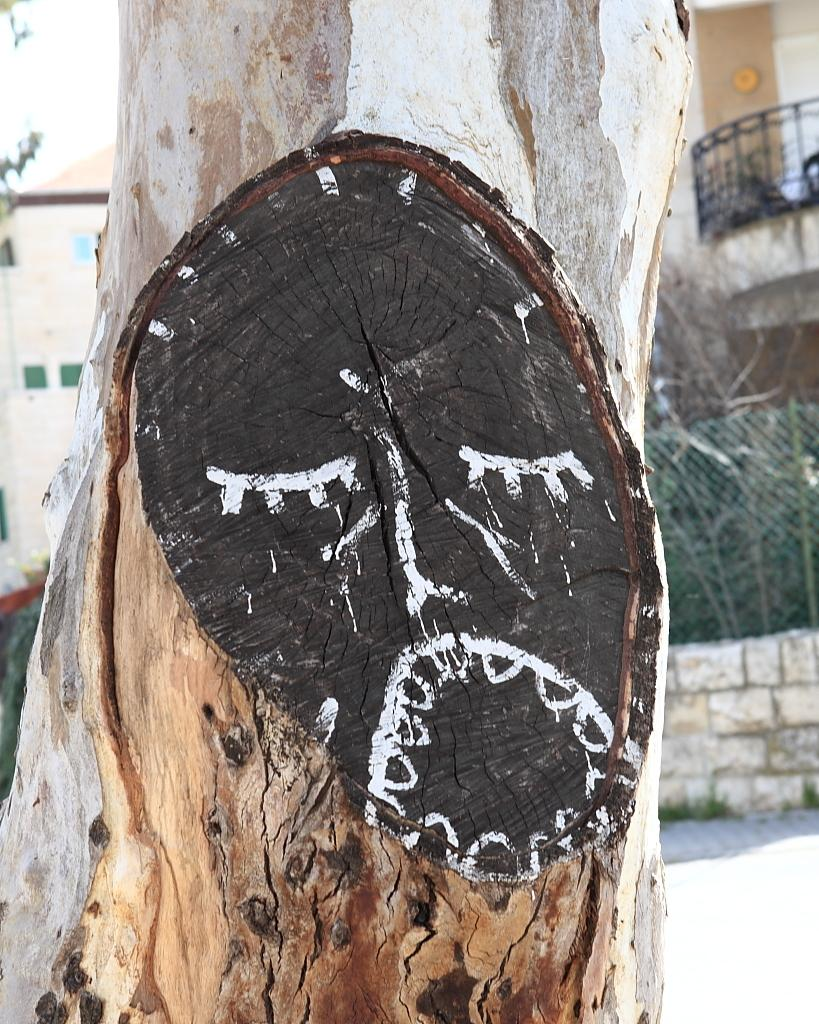What type of vegetation is present in the image? There is a tree in the image. What is located on the right side of the image? There is a wall and fencing on the right side of the image. What can be seen in the background of the image? There are buildings in the background of the image. What is at the bottom of the image? There is a road at the bottom of the image. What type of alarm is ringing in the yard in the image? There is no alarm or yard present in the image. 